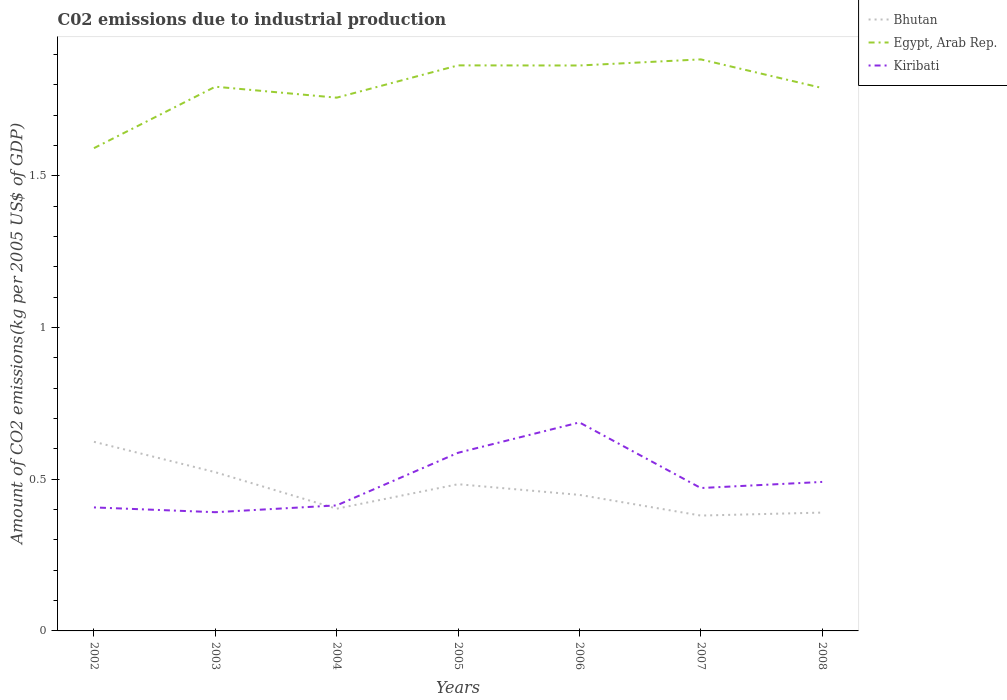How many different coloured lines are there?
Provide a succinct answer. 3. Does the line corresponding to Kiribati intersect with the line corresponding to Egypt, Arab Rep.?
Make the answer very short. No. Is the number of lines equal to the number of legend labels?
Your response must be concise. Yes. Across all years, what is the maximum amount of CO2 emitted due to industrial production in Kiribati?
Keep it short and to the point. 0.39. What is the total amount of CO2 emitted due to industrial production in Egypt, Arab Rep. in the graph?
Make the answer very short. -0.27. What is the difference between the highest and the second highest amount of CO2 emitted due to industrial production in Egypt, Arab Rep.?
Provide a succinct answer. 0.29. How many years are there in the graph?
Offer a very short reply. 7. Does the graph contain grids?
Your answer should be compact. No. How are the legend labels stacked?
Offer a very short reply. Vertical. What is the title of the graph?
Make the answer very short. C02 emissions due to industrial production. What is the label or title of the X-axis?
Make the answer very short. Years. What is the label or title of the Y-axis?
Your response must be concise. Amount of CO2 emissions(kg per 2005 US$ of GDP). What is the Amount of CO2 emissions(kg per 2005 US$ of GDP) in Bhutan in 2002?
Your answer should be very brief. 0.62. What is the Amount of CO2 emissions(kg per 2005 US$ of GDP) in Egypt, Arab Rep. in 2002?
Provide a short and direct response. 1.59. What is the Amount of CO2 emissions(kg per 2005 US$ of GDP) in Kiribati in 2002?
Ensure brevity in your answer.  0.41. What is the Amount of CO2 emissions(kg per 2005 US$ of GDP) in Bhutan in 2003?
Provide a short and direct response. 0.52. What is the Amount of CO2 emissions(kg per 2005 US$ of GDP) of Egypt, Arab Rep. in 2003?
Ensure brevity in your answer.  1.79. What is the Amount of CO2 emissions(kg per 2005 US$ of GDP) of Kiribati in 2003?
Your response must be concise. 0.39. What is the Amount of CO2 emissions(kg per 2005 US$ of GDP) in Bhutan in 2004?
Keep it short and to the point. 0.4. What is the Amount of CO2 emissions(kg per 2005 US$ of GDP) of Egypt, Arab Rep. in 2004?
Offer a very short reply. 1.76. What is the Amount of CO2 emissions(kg per 2005 US$ of GDP) in Kiribati in 2004?
Keep it short and to the point. 0.41. What is the Amount of CO2 emissions(kg per 2005 US$ of GDP) of Bhutan in 2005?
Offer a terse response. 0.48. What is the Amount of CO2 emissions(kg per 2005 US$ of GDP) of Egypt, Arab Rep. in 2005?
Give a very brief answer. 1.86. What is the Amount of CO2 emissions(kg per 2005 US$ of GDP) in Kiribati in 2005?
Provide a short and direct response. 0.59. What is the Amount of CO2 emissions(kg per 2005 US$ of GDP) of Bhutan in 2006?
Provide a succinct answer. 0.45. What is the Amount of CO2 emissions(kg per 2005 US$ of GDP) in Egypt, Arab Rep. in 2006?
Give a very brief answer. 1.86. What is the Amount of CO2 emissions(kg per 2005 US$ of GDP) in Kiribati in 2006?
Your response must be concise. 0.69. What is the Amount of CO2 emissions(kg per 2005 US$ of GDP) in Bhutan in 2007?
Your response must be concise. 0.38. What is the Amount of CO2 emissions(kg per 2005 US$ of GDP) in Egypt, Arab Rep. in 2007?
Give a very brief answer. 1.88. What is the Amount of CO2 emissions(kg per 2005 US$ of GDP) of Kiribati in 2007?
Provide a short and direct response. 0.47. What is the Amount of CO2 emissions(kg per 2005 US$ of GDP) in Bhutan in 2008?
Your answer should be compact. 0.39. What is the Amount of CO2 emissions(kg per 2005 US$ of GDP) in Egypt, Arab Rep. in 2008?
Your response must be concise. 1.79. What is the Amount of CO2 emissions(kg per 2005 US$ of GDP) of Kiribati in 2008?
Offer a terse response. 0.49. Across all years, what is the maximum Amount of CO2 emissions(kg per 2005 US$ of GDP) in Bhutan?
Offer a terse response. 0.62. Across all years, what is the maximum Amount of CO2 emissions(kg per 2005 US$ of GDP) in Egypt, Arab Rep.?
Give a very brief answer. 1.88. Across all years, what is the maximum Amount of CO2 emissions(kg per 2005 US$ of GDP) of Kiribati?
Your answer should be compact. 0.69. Across all years, what is the minimum Amount of CO2 emissions(kg per 2005 US$ of GDP) in Bhutan?
Provide a short and direct response. 0.38. Across all years, what is the minimum Amount of CO2 emissions(kg per 2005 US$ of GDP) in Egypt, Arab Rep.?
Keep it short and to the point. 1.59. Across all years, what is the minimum Amount of CO2 emissions(kg per 2005 US$ of GDP) in Kiribati?
Your answer should be compact. 0.39. What is the total Amount of CO2 emissions(kg per 2005 US$ of GDP) of Bhutan in the graph?
Make the answer very short. 3.25. What is the total Amount of CO2 emissions(kg per 2005 US$ of GDP) in Egypt, Arab Rep. in the graph?
Your answer should be compact. 12.55. What is the total Amount of CO2 emissions(kg per 2005 US$ of GDP) in Kiribati in the graph?
Your response must be concise. 3.45. What is the difference between the Amount of CO2 emissions(kg per 2005 US$ of GDP) in Bhutan in 2002 and that in 2003?
Your answer should be very brief. 0.1. What is the difference between the Amount of CO2 emissions(kg per 2005 US$ of GDP) in Egypt, Arab Rep. in 2002 and that in 2003?
Ensure brevity in your answer.  -0.2. What is the difference between the Amount of CO2 emissions(kg per 2005 US$ of GDP) in Kiribati in 2002 and that in 2003?
Provide a succinct answer. 0.02. What is the difference between the Amount of CO2 emissions(kg per 2005 US$ of GDP) of Bhutan in 2002 and that in 2004?
Offer a terse response. 0.22. What is the difference between the Amount of CO2 emissions(kg per 2005 US$ of GDP) of Egypt, Arab Rep. in 2002 and that in 2004?
Your answer should be very brief. -0.17. What is the difference between the Amount of CO2 emissions(kg per 2005 US$ of GDP) of Kiribati in 2002 and that in 2004?
Ensure brevity in your answer.  -0.01. What is the difference between the Amount of CO2 emissions(kg per 2005 US$ of GDP) in Bhutan in 2002 and that in 2005?
Ensure brevity in your answer.  0.14. What is the difference between the Amount of CO2 emissions(kg per 2005 US$ of GDP) of Egypt, Arab Rep. in 2002 and that in 2005?
Make the answer very short. -0.27. What is the difference between the Amount of CO2 emissions(kg per 2005 US$ of GDP) in Kiribati in 2002 and that in 2005?
Give a very brief answer. -0.18. What is the difference between the Amount of CO2 emissions(kg per 2005 US$ of GDP) in Bhutan in 2002 and that in 2006?
Your answer should be very brief. 0.18. What is the difference between the Amount of CO2 emissions(kg per 2005 US$ of GDP) of Egypt, Arab Rep. in 2002 and that in 2006?
Offer a terse response. -0.27. What is the difference between the Amount of CO2 emissions(kg per 2005 US$ of GDP) in Kiribati in 2002 and that in 2006?
Your answer should be very brief. -0.28. What is the difference between the Amount of CO2 emissions(kg per 2005 US$ of GDP) of Bhutan in 2002 and that in 2007?
Your response must be concise. 0.24. What is the difference between the Amount of CO2 emissions(kg per 2005 US$ of GDP) of Egypt, Arab Rep. in 2002 and that in 2007?
Keep it short and to the point. -0.29. What is the difference between the Amount of CO2 emissions(kg per 2005 US$ of GDP) in Kiribati in 2002 and that in 2007?
Provide a succinct answer. -0.06. What is the difference between the Amount of CO2 emissions(kg per 2005 US$ of GDP) in Bhutan in 2002 and that in 2008?
Make the answer very short. 0.23. What is the difference between the Amount of CO2 emissions(kg per 2005 US$ of GDP) of Egypt, Arab Rep. in 2002 and that in 2008?
Make the answer very short. -0.2. What is the difference between the Amount of CO2 emissions(kg per 2005 US$ of GDP) in Kiribati in 2002 and that in 2008?
Your answer should be compact. -0.08. What is the difference between the Amount of CO2 emissions(kg per 2005 US$ of GDP) of Bhutan in 2003 and that in 2004?
Keep it short and to the point. 0.12. What is the difference between the Amount of CO2 emissions(kg per 2005 US$ of GDP) of Egypt, Arab Rep. in 2003 and that in 2004?
Keep it short and to the point. 0.04. What is the difference between the Amount of CO2 emissions(kg per 2005 US$ of GDP) in Kiribati in 2003 and that in 2004?
Give a very brief answer. -0.02. What is the difference between the Amount of CO2 emissions(kg per 2005 US$ of GDP) of Bhutan in 2003 and that in 2005?
Offer a very short reply. 0.04. What is the difference between the Amount of CO2 emissions(kg per 2005 US$ of GDP) in Egypt, Arab Rep. in 2003 and that in 2005?
Provide a succinct answer. -0.07. What is the difference between the Amount of CO2 emissions(kg per 2005 US$ of GDP) of Kiribati in 2003 and that in 2005?
Provide a short and direct response. -0.2. What is the difference between the Amount of CO2 emissions(kg per 2005 US$ of GDP) of Bhutan in 2003 and that in 2006?
Provide a short and direct response. 0.07. What is the difference between the Amount of CO2 emissions(kg per 2005 US$ of GDP) of Egypt, Arab Rep. in 2003 and that in 2006?
Offer a terse response. -0.07. What is the difference between the Amount of CO2 emissions(kg per 2005 US$ of GDP) in Kiribati in 2003 and that in 2006?
Keep it short and to the point. -0.3. What is the difference between the Amount of CO2 emissions(kg per 2005 US$ of GDP) in Bhutan in 2003 and that in 2007?
Your response must be concise. 0.14. What is the difference between the Amount of CO2 emissions(kg per 2005 US$ of GDP) in Egypt, Arab Rep. in 2003 and that in 2007?
Your answer should be very brief. -0.09. What is the difference between the Amount of CO2 emissions(kg per 2005 US$ of GDP) in Kiribati in 2003 and that in 2007?
Provide a short and direct response. -0.08. What is the difference between the Amount of CO2 emissions(kg per 2005 US$ of GDP) of Bhutan in 2003 and that in 2008?
Offer a terse response. 0.13. What is the difference between the Amount of CO2 emissions(kg per 2005 US$ of GDP) of Egypt, Arab Rep. in 2003 and that in 2008?
Your answer should be compact. 0. What is the difference between the Amount of CO2 emissions(kg per 2005 US$ of GDP) in Kiribati in 2003 and that in 2008?
Provide a succinct answer. -0.1. What is the difference between the Amount of CO2 emissions(kg per 2005 US$ of GDP) of Bhutan in 2004 and that in 2005?
Your answer should be very brief. -0.08. What is the difference between the Amount of CO2 emissions(kg per 2005 US$ of GDP) in Egypt, Arab Rep. in 2004 and that in 2005?
Offer a very short reply. -0.11. What is the difference between the Amount of CO2 emissions(kg per 2005 US$ of GDP) of Kiribati in 2004 and that in 2005?
Your answer should be very brief. -0.17. What is the difference between the Amount of CO2 emissions(kg per 2005 US$ of GDP) in Bhutan in 2004 and that in 2006?
Your answer should be compact. -0.05. What is the difference between the Amount of CO2 emissions(kg per 2005 US$ of GDP) of Egypt, Arab Rep. in 2004 and that in 2006?
Your answer should be compact. -0.11. What is the difference between the Amount of CO2 emissions(kg per 2005 US$ of GDP) in Kiribati in 2004 and that in 2006?
Offer a terse response. -0.27. What is the difference between the Amount of CO2 emissions(kg per 2005 US$ of GDP) of Bhutan in 2004 and that in 2007?
Keep it short and to the point. 0.02. What is the difference between the Amount of CO2 emissions(kg per 2005 US$ of GDP) in Egypt, Arab Rep. in 2004 and that in 2007?
Offer a terse response. -0.13. What is the difference between the Amount of CO2 emissions(kg per 2005 US$ of GDP) of Kiribati in 2004 and that in 2007?
Ensure brevity in your answer.  -0.06. What is the difference between the Amount of CO2 emissions(kg per 2005 US$ of GDP) of Bhutan in 2004 and that in 2008?
Offer a terse response. 0.01. What is the difference between the Amount of CO2 emissions(kg per 2005 US$ of GDP) in Egypt, Arab Rep. in 2004 and that in 2008?
Ensure brevity in your answer.  -0.03. What is the difference between the Amount of CO2 emissions(kg per 2005 US$ of GDP) in Kiribati in 2004 and that in 2008?
Give a very brief answer. -0.08. What is the difference between the Amount of CO2 emissions(kg per 2005 US$ of GDP) in Bhutan in 2005 and that in 2006?
Ensure brevity in your answer.  0.04. What is the difference between the Amount of CO2 emissions(kg per 2005 US$ of GDP) in Egypt, Arab Rep. in 2005 and that in 2006?
Offer a very short reply. 0. What is the difference between the Amount of CO2 emissions(kg per 2005 US$ of GDP) of Kiribati in 2005 and that in 2006?
Ensure brevity in your answer.  -0.1. What is the difference between the Amount of CO2 emissions(kg per 2005 US$ of GDP) of Bhutan in 2005 and that in 2007?
Keep it short and to the point. 0.1. What is the difference between the Amount of CO2 emissions(kg per 2005 US$ of GDP) of Egypt, Arab Rep. in 2005 and that in 2007?
Make the answer very short. -0.02. What is the difference between the Amount of CO2 emissions(kg per 2005 US$ of GDP) in Kiribati in 2005 and that in 2007?
Your answer should be very brief. 0.12. What is the difference between the Amount of CO2 emissions(kg per 2005 US$ of GDP) in Bhutan in 2005 and that in 2008?
Your answer should be very brief. 0.09. What is the difference between the Amount of CO2 emissions(kg per 2005 US$ of GDP) in Egypt, Arab Rep. in 2005 and that in 2008?
Your answer should be very brief. 0.07. What is the difference between the Amount of CO2 emissions(kg per 2005 US$ of GDP) of Kiribati in 2005 and that in 2008?
Ensure brevity in your answer.  0.1. What is the difference between the Amount of CO2 emissions(kg per 2005 US$ of GDP) of Bhutan in 2006 and that in 2007?
Give a very brief answer. 0.07. What is the difference between the Amount of CO2 emissions(kg per 2005 US$ of GDP) of Egypt, Arab Rep. in 2006 and that in 2007?
Your answer should be very brief. -0.02. What is the difference between the Amount of CO2 emissions(kg per 2005 US$ of GDP) in Kiribati in 2006 and that in 2007?
Give a very brief answer. 0.22. What is the difference between the Amount of CO2 emissions(kg per 2005 US$ of GDP) of Bhutan in 2006 and that in 2008?
Keep it short and to the point. 0.06. What is the difference between the Amount of CO2 emissions(kg per 2005 US$ of GDP) in Egypt, Arab Rep. in 2006 and that in 2008?
Your response must be concise. 0.07. What is the difference between the Amount of CO2 emissions(kg per 2005 US$ of GDP) in Kiribati in 2006 and that in 2008?
Keep it short and to the point. 0.2. What is the difference between the Amount of CO2 emissions(kg per 2005 US$ of GDP) in Bhutan in 2007 and that in 2008?
Your answer should be compact. -0.01. What is the difference between the Amount of CO2 emissions(kg per 2005 US$ of GDP) of Egypt, Arab Rep. in 2007 and that in 2008?
Give a very brief answer. 0.09. What is the difference between the Amount of CO2 emissions(kg per 2005 US$ of GDP) in Kiribati in 2007 and that in 2008?
Provide a succinct answer. -0.02. What is the difference between the Amount of CO2 emissions(kg per 2005 US$ of GDP) in Bhutan in 2002 and the Amount of CO2 emissions(kg per 2005 US$ of GDP) in Egypt, Arab Rep. in 2003?
Offer a very short reply. -1.17. What is the difference between the Amount of CO2 emissions(kg per 2005 US$ of GDP) of Bhutan in 2002 and the Amount of CO2 emissions(kg per 2005 US$ of GDP) of Kiribati in 2003?
Provide a succinct answer. 0.23. What is the difference between the Amount of CO2 emissions(kg per 2005 US$ of GDP) in Egypt, Arab Rep. in 2002 and the Amount of CO2 emissions(kg per 2005 US$ of GDP) in Kiribati in 2003?
Offer a terse response. 1.2. What is the difference between the Amount of CO2 emissions(kg per 2005 US$ of GDP) in Bhutan in 2002 and the Amount of CO2 emissions(kg per 2005 US$ of GDP) in Egypt, Arab Rep. in 2004?
Ensure brevity in your answer.  -1.13. What is the difference between the Amount of CO2 emissions(kg per 2005 US$ of GDP) of Bhutan in 2002 and the Amount of CO2 emissions(kg per 2005 US$ of GDP) of Kiribati in 2004?
Make the answer very short. 0.21. What is the difference between the Amount of CO2 emissions(kg per 2005 US$ of GDP) in Egypt, Arab Rep. in 2002 and the Amount of CO2 emissions(kg per 2005 US$ of GDP) in Kiribati in 2004?
Provide a short and direct response. 1.18. What is the difference between the Amount of CO2 emissions(kg per 2005 US$ of GDP) of Bhutan in 2002 and the Amount of CO2 emissions(kg per 2005 US$ of GDP) of Egypt, Arab Rep. in 2005?
Give a very brief answer. -1.24. What is the difference between the Amount of CO2 emissions(kg per 2005 US$ of GDP) in Bhutan in 2002 and the Amount of CO2 emissions(kg per 2005 US$ of GDP) in Kiribati in 2005?
Your answer should be compact. 0.04. What is the difference between the Amount of CO2 emissions(kg per 2005 US$ of GDP) in Egypt, Arab Rep. in 2002 and the Amount of CO2 emissions(kg per 2005 US$ of GDP) in Kiribati in 2005?
Provide a short and direct response. 1. What is the difference between the Amount of CO2 emissions(kg per 2005 US$ of GDP) in Bhutan in 2002 and the Amount of CO2 emissions(kg per 2005 US$ of GDP) in Egypt, Arab Rep. in 2006?
Give a very brief answer. -1.24. What is the difference between the Amount of CO2 emissions(kg per 2005 US$ of GDP) of Bhutan in 2002 and the Amount of CO2 emissions(kg per 2005 US$ of GDP) of Kiribati in 2006?
Keep it short and to the point. -0.06. What is the difference between the Amount of CO2 emissions(kg per 2005 US$ of GDP) in Egypt, Arab Rep. in 2002 and the Amount of CO2 emissions(kg per 2005 US$ of GDP) in Kiribati in 2006?
Your answer should be very brief. 0.9. What is the difference between the Amount of CO2 emissions(kg per 2005 US$ of GDP) in Bhutan in 2002 and the Amount of CO2 emissions(kg per 2005 US$ of GDP) in Egypt, Arab Rep. in 2007?
Ensure brevity in your answer.  -1.26. What is the difference between the Amount of CO2 emissions(kg per 2005 US$ of GDP) in Bhutan in 2002 and the Amount of CO2 emissions(kg per 2005 US$ of GDP) in Kiribati in 2007?
Give a very brief answer. 0.15. What is the difference between the Amount of CO2 emissions(kg per 2005 US$ of GDP) in Egypt, Arab Rep. in 2002 and the Amount of CO2 emissions(kg per 2005 US$ of GDP) in Kiribati in 2007?
Provide a short and direct response. 1.12. What is the difference between the Amount of CO2 emissions(kg per 2005 US$ of GDP) of Bhutan in 2002 and the Amount of CO2 emissions(kg per 2005 US$ of GDP) of Egypt, Arab Rep. in 2008?
Your response must be concise. -1.17. What is the difference between the Amount of CO2 emissions(kg per 2005 US$ of GDP) in Bhutan in 2002 and the Amount of CO2 emissions(kg per 2005 US$ of GDP) in Kiribati in 2008?
Your response must be concise. 0.13. What is the difference between the Amount of CO2 emissions(kg per 2005 US$ of GDP) of Egypt, Arab Rep. in 2002 and the Amount of CO2 emissions(kg per 2005 US$ of GDP) of Kiribati in 2008?
Your answer should be compact. 1.1. What is the difference between the Amount of CO2 emissions(kg per 2005 US$ of GDP) of Bhutan in 2003 and the Amount of CO2 emissions(kg per 2005 US$ of GDP) of Egypt, Arab Rep. in 2004?
Ensure brevity in your answer.  -1.23. What is the difference between the Amount of CO2 emissions(kg per 2005 US$ of GDP) of Bhutan in 2003 and the Amount of CO2 emissions(kg per 2005 US$ of GDP) of Kiribati in 2004?
Your response must be concise. 0.11. What is the difference between the Amount of CO2 emissions(kg per 2005 US$ of GDP) of Egypt, Arab Rep. in 2003 and the Amount of CO2 emissions(kg per 2005 US$ of GDP) of Kiribati in 2004?
Give a very brief answer. 1.38. What is the difference between the Amount of CO2 emissions(kg per 2005 US$ of GDP) in Bhutan in 2003 and the Amount of CO2 emissions(kg per 2005 US$ of GDP) in Egypt, Arab Rep. in 2005?
Offer a very short reply. -1.34. What is the difference between the Amount of CO2 emissions(kg per 2005 US$ of GDP) of Bhutan in 2003 and the Amount of CO2 emissions(kg per 2005 US$ of GDP) of Kiribati in 2005?
Provide a short and direct response. -0.06. What is the difference between the Amount of CO2 emissions(kg per 2005 US$ of GDP) in Egypt, Arab Rep. in 2003 and the Amount of CO2 emissions(kg per 2005 US$ of GDP) in Kiribati in 2005?
Provide a short and direct response. 1.21. What is the difference between the Amount of CO2 emissions(kg per 2005 US$ of GDP) in Bhutan in 2003 and the Amount of CO2 emissions(kg per 2005 US$ of GDP) in Egypt, Arab Rep. in 2006?
Give a very brief answer. -1.34. What is the difference between the Amount of CO2 emissions(kg per 2005 US$ of GDP) of Bhutan in 2003 and the Amount of CO2 emissions(kg per 2005 US$ of GDP) of Kiribati in 2006?
Make the answer very short. -0.16. What is the difference between the Amount of CO2 emissions(kg per 2005 US$ of GDP) of Egypt, Arab Rep. in 2003 and the Amount of CO2 emissions(kg per 2005 US$ of GDP) of Kiribati in 2006?
Offer a terse response. 1.11. What is the difference between the Amount of CO2 emissions(kg per 2005 US$ of GDP) in Bhutan in 2003 and the Amount of CO2 emissions(kg per 2005 US$ of GDP) in Egypt, Arab Rep. in 2007?
Offer a terse response. -1.36. What is the difference between the Amount of CO2 emissions(kg per 2005 US$ of GDP) of Bhutan in 2003 and the Amount of CO2 emissions(kg per 2005 US$ of GDP) of Kiribati in 2007?
Offer a terse response. 0.05. What is the difference between the Amount of CO2 emissions(kg per 2005 US$ of GDP) in Egypt, Arab Rep. in 2003 and the Amount of CO2 emissions(kg per 2005 US$ of GDP) in Kiribati in 2007?
Make the answer very short. 1.32. What is the difference between the Amount of CO2 emissions(kg per 2005 US$ of GDP) of Bhutan in 2003 and the Amount of CO2 emissions(kg per 2005 US$ of GDP) of Egypt, Arab Rep. in 2008?
Make the answer very short. -1.27. What is the difference between the Amount of CO2 emissions(kg per 2005 US$ of GDP) of Bhutan in 2003 and the Amount of CO2 emissions(kg per 2005 US$ of GDP) of Kiribati in 2008?
Your answer should be compact. 0.03. What is the difference between the Amount of CO2 emissions(kg per 2005 US$ of GDP) of Egypt, Arab Rep. in 2003 and the Amount of CO2 emissions(kg per 2005 US$ of GDP) of Kiribati in 2008?
Provide a succinct answer. 1.3. What is the difference between the Amount of CO2 emissions(kg per 2005 US$ of GDP) in Bhutan in 2004 and the Amount of CO2 emissions(kg per 2005 US$ of GDP) in Egypt, Arab Rep. in 2005?
Your response must be concise. -1.46. What is the difference between the Amount of CO2 emissions(kg per 2005 US$ of GDP) in Bhutan in 2004 and the Amount of CO2 emissions(kg per 2005 US$ of GDP) in Kiribati in 2005?
Offer a very short reply. -0.18. What is the difference between the Amount of CO2 emissions(kg per 2005 US$ of GDP) of Egypt, Arab Rep. in 2004 and the Amount of CO2 emissions(kg per 2005 US$ of GDP) of Kiribati in 2005?
Give a very brief answer. 1.17. What is the difference between the Amount of CO2 emissions(kg per 2005 US$ of GDP) in Bhutan in 2004 and the Amount of CO2 emissions(kg per 2005 US$ of GDP) in Egypt, Arab Rep. in 2006?
Offer a terse response. -1.46. What is the difference between the Amount of CO2 emissions(kg per 2005 US$ of GDP) of Bhutan in 2004 and the Amount of CO2 emissions(kg per 2005 US$ of GDP) of Kiribati in 2006?
Your response must be concise. -0.28. What is the difference between the Amount of CO2 emissions(kg per 2005 US$ of GDP) in Egypt, Arab Rep. in 2004 and the Amount of CO2 emissions(kg per 2005 US$ of GDP) in Kiribati in 2006?
Your answer should be very brief. 1.07. What is the difference between the Amount of CO2 emissions(kg per 2005 US$ of GDP) of Bhutan in 2004 and the Amount of CO2 emissions(kg per 2005 US$ of GDP) of Egypt, Arab Rep. in 2007?
Keep it short and to the point. -1.48. What is the difference between the Amount of CO2 emissions(kg per 2005 US$ of GDP) in Bhutan in 2004 and the Amount of CO2 emissions(kg per 2005 US$ of GDP) in Kiribati in 2007?
Your response must be concise. -0.07. What is the difference between the Amount of CO2 emissions(kg per 2005 US$ of GDP) of Egypt, Arab Rep. in 2004 and the Amount of CO2 emissions(kg per 2005 US$ of GDP) of Kiribati in 2007?
Ensure brevity in your answer.  1.29. What is the difference between the Amount of CO2 emissions(kg per 2005 US$ of GDP) of Bhutan in 2004 and the Amount of CO2 emissions(kg per 2005 US$ of GDP) of Egypt, Arab Rep. in 2008?
Your answer should be compact. -1.39. What is the difference between the Amount of CO2 emissions(kg per 2005 US$ of GDP) in Bhutan in 2004 and the Amount of CO2 emissions(kg per 2005 US$ of GDP) in Kiribati in 2008?
Your response must be concise. -0.09. What is the difference between the Amount of CO2 emissions(kg per 2005 US$ of GDP) of Egypt, Arab Rep. in 2004 and the Amount of CO2 emissions(kg per 2005 US$ of GDP) of Kiribati in 2008?
Provide a succinct answer. 1.27. What is the difference between the Amount of CO2 emissions(kg per 2005 US$ of GDP) of Bhutan in 2005 and the Amount of CO2 emissions(kg per 2005 US$ of GDP) of Egypt, Arab Rep. in 2006?
Keep it short and to the point. -1.38. What is the difference between the Amount of CO2 emissions(kg per 2005 US$ of GDP) in Bhutan in 2005 and the Amount of CO2 emissions(kg per 2005 US$ of GDP) in Kiribati in 2006?
Offer a very short reply. -0.2. What is the difference between the Amount of CO2 emissions(kg per 2005 US$ of GDP) of Egypt, Arab Rep. in 2005 and the Amount of CO2 emissions(kg per 2005 US$ of GDP) of Kiribati in 2006?
Give a very brief answer. 1.18. What is the difference between the Amount of CO2 emissions(kg per 2005 US$ of GDP) in Bhutan in 2005 and the Amount of CO2 emissions(kg per 2005 US$ of GDP) in Egypt, Arab Rep. in 2007?
Your answer should be compact. -1.4. What is the difference between the Amount of CO2 emissions(kg per 2005 US$ of GDP) in Bhutan in 2005 and the Amount of CO2 emissions(kg per 2005 US$ of GDP) in Kiribati in 2007?
Provide a short and direct response. 0.01. What is the difference between the Amount of CO2 emissions(kg per 2005 US$ of GDP) in Egypt, Arab Rep. in 2005 and the Amount of CO2 emissions(kg per 2005 US$ of GDP) in Kiribati in 2007?
Offer a very short reply. 1.39. What is the difference between the Amount of CO2 emissions(kg per 2005 US$ of GDP) in Bhutan in 2005 and the Amount of CO2 emissions(kg per 2005 US$ of GDP) in Egypt, Arab Rep. in 2008?
Your answer should be very brief. -1.31. What is the difference between the Amount of CO2 emissions(kg per 2005 US$ of GDP) of Bhutan in 2005 and the Amount of CO2 emissions(kg per 2005 US$ of GDP) of Kiribati in 2008?
Make the answer very short. -0.01. What is the difference between the Amount of CO2 emissions(kg per 2005 US$ of GDP) of Egypt, Arab Rep. in 2005 and the Amount of CO2 emissions(kg per 2005 US$ of GDP) of Kiribati in 2008?
Provide a succinct answer. 1.37. What is the difference between the Amount of CO2 emissions(kg per 2005 US$ of GDP) in Bhutan in 2006 and the Amount of CO2 emissions(kg per 2005 US$ of GDP) in Egypt, Arab Rep. in 2007?
Provide a succinct answer. -1.44. What is the difference between the Amount of CO2 emissions(kg per 2005 US$ of GDP) in Bhutan in 2006 and the Amount of CO2 emissions(kg per 2005 US$ of GDP) in Kiribati in 2007?
Provide a short and direct response. -0.02. What is the difference between the Amount of CO2 emissions(kg per 2005 US$ of GDP) of Egypt, Arab Rep. in 2006 and the Amount of CO2 emissions(kg per 2005 US$ of GDP) of Kiribati in 2007?
Provide a short and direct response. 1.39. What is the difference between the Amount of CO2 emissions(kg per 2005 US$ of GDP) of Bhutan in 2006 and the Amount of CO2 emissions(kg per 2005 US$ of GDP) of Egypt, Arab Rep. in 2008?
Make the answer very short. -1.34. What is the difference between the Amount of CO2 emissions(kg per 2005 US$ of GDP) of Bhutan in 2006 and the Amount of CO2 emissions(kg per 2005 US$ of GDP) of Kiribati in 2008?
Your response must be concise. -0.04. What is the difference between the Amount of CO2 emissions(kg per 2005 US$ of GDP) of Egypt, Arab Rep. in 2006 and the Amount of CO2 emissions(kg per 2005 US$ of GDP) of Kiribati in 2008?
Ensure brevity in your answer.  1.37. What is the difference between the Amount of CO2 emissions(kg per 2005 US$ of GDP) of Bhutan in 2007 and the Amount of CO2 emissions(kg per 2005 US$ of GDP) of Egypt, Arab Rep. in 2008?
Make the answer very short. -1.41. What is the difference between the Amount of CO2 emissions(kg per 2005 US$ of GDP) of Bhutan in 2007 and the Amount of CO2 emissions(kg per 2005 US$ of GDP) of Kiribati in 2008?
Provide a short and direct response. -0.11. What is the difference between the Amount of CO2 emissions(kg per 2005 US$ of GDP) of Egypt, Arab Rep. in 2007 and the Amount of CO2 emissions(kg per 2005 US$ of GDP) of Kiribati in 2008?
Make the answer very short. 1.39. What is the average Amount of CO2 emissions(kg per 2005 US$ of GDP) of Bhutan per year?
Offer a terse response. 0.46. What is the average Amount of CO2 emissions(kg per 2005 US$ of GDP) of Egypt, Arab Rep. per year?
Offer a very short reply. 1.79. What is the average Amount of CO2 emissions(kg per 2005 US$ of GDP) in Kiribati per year?
Your response must be concise. 0.49. In the year 2002, what is the difference between the Amount of CO2 emissions(kg per 2005 US$ of GDP) of Bhutan and Amount of CO2 emissions(kg per 2005 US$ of GDP) of Egypt, Arab Rep.?
Offer a terse response. -0.97. In the year 2002, what is the difference between the Amount of CO2 emissions(kg per 2005 US$ of GDP) of Bhutan and Amount of CO2 emissions(kg per 2005 US$ of GDP) of Kiribati?
Ensure brevity in your answer.  0.22. In the year 2002, what is the difference between the Amount of CO2 emissions(kg per 2005 US$ of GDP) in Egypt, Arab Rep. and Amount of CO2 emissions(kg per 2005 US$ of GDP) in Kiribati?
Offer a terse response. 1.18. In the year 2003, what is the difference between the Amount of CO2 emissions(kg per 2005 US$ of GDP) of Bhutan and Amount of CO2 emissions(kg per 2005 US$ of GDP) of Egypt, Arab Rep.?
Give a very brief answer. -1.27. In the year 2003, what is the difference between the Amount of CO2 emissions(kg per 2005 US$ of GDP) in Bhutan and Amount of CO2 emissions(kg per 2005 US$ of GDP) in Kiribati?
Offer a terse response. 0.13. In the year 2003, what is the difference between the Amount of CO2 emissions(kg per 2005 US$ of GDP) of Egypt, Arab Rep. and Amount of CO2 emissions(kg per 2005 US$ of GDP) of Kiribati?
Give a very brief answer. 1.4. In the year 2004, what is the difference between the Amount of CO2 emissions(kg per 2005 US$ of GDP) in Bhutan and Amount of CO2 emissions(kg per 2005 US$ of GDP) in Egypt, Arab Rep.?
Make the answer very short. -1.35. In the year 2004, what is the difference between the Amount of CO2 emissions(kg per 2005 US$ of GDP) of Bhutan and Amount of CO2 emissions(kg per 2005 US$ of GDP) of Kiribati?
Provide a short and direct response. -0.01. In the year 2004, what is the difference between the Amount of CO2 emissions(kg per 2005 US$ of GDP) of Egypt, Arab Rep. and Amount of CO2 emissions(kg per 2005 US$ of GDP) of Kiribati?
Give a very brief answer. 1.34. In the year 2005, what is the difference between the Amount of CO2 emissions(kg per 2005 US$ of GDP) of Bhutan and Amount of CO2 emissions(kg per 2005 US$ of GDP) of Egypt, Arab Rep.?
Your answer should be very brief. -1.38. In the year 2005, what is the difference between the Amount of CO2 emissions(kg per 2005 US$ of GDP) of Bhutan and Amount of CO2 emissions(kg per 2005 US$ of GDP) of Kiribati?
Provide a succinct answer. -0.1. In the year 2005, what is the difference between the Amount of CO2 emissions(kg per 2005 US$ of GDP) of Egypt, Arab Rep. and Amount of CO2 emissions(kg per 2005 US$ of GDP) of Kiribati?
Your response must be concise. 1.28. In the year 2006, what is the difference between the Amount of CO2 emissions(kg per 2005 US$ of GDP) of Bhutan and Amount of CO2 emissions(kg per 2005 US$ of GDP) of Egypt, Arab Rep.?
Provide a succinct answer. -1.42. In the year 2006, what is the difference between the Amount of CO2 emissions(kg per 2005 US$ of GDP) of Bhutan and Amount of CO2 emissions(kg per 2005 US$ of GDP) of Kiribati?
Your response must be concise. -0.24. In the year 2006, what is the difference between the Amount of CO2 emissions(kg per 2005 US$ of GDP) in Egypt, Arab Rep. and Amount of CO2 emissions(kg per 2005 US$ of GDP) in Kiribati?
Your answer should be compact. 1.18. In the year 2007, what is the difference between the Amount of CO2 emissions(kg per 2005 US$ of GDP) of Bhutan and Amount of CO2 emissions(kg per 2005 US$ of GDP) of Egypt, Arab Rep.?
Your answer should be very brief. -1.5. In the year 2007, what is the difference between the Amount of CO2 emissions(kg per 2005 US$ of GDP) in Bhutan and Amount of CO2 emissions(kg per 2005 US$ of GDP) in Kiribati?
Your answer should be very brief. -0.09. In the year 2007, what is the difference between the Amount of CO2 emissions(kg per 2005 US$ of GDP) in Egypt, Arab Rep. and Amount of CO2 emissions(kg per 2005 US$ of GDP) in Kiribati?
Give a very brief answer. 1.41. In the year 2008, what is the difference between the Amount of CO2 emissions(kg per 2005 US$ of GDP) of Bhutan and Amount of CO2 emissions(kg per 2005 US$ of GDP) of Egypt, Arab Rep.?
Keep it short and to the point. -1.4. In the year 2008, what is the difference between the Amount of CO2 emissions(kg per 2005 US$ of GDP) of Bhutan and Amount of CO2 emissions(kg per 2005 US$ of GDP) of Kiribati?
Give a very brief answer. -0.1. In the year 2008, what is the difference between the Amount of CO2 emissions(kg per 2005 US$ of GDP) in Egypt, Arab Rep. and Amount of CO2 emissions(kg per 2005 US$ of GDP) in Kiribati?
Your answer should be very brief. 1.3. What is the ratio of the Amount of CO2 emissions(kg per 2005 US$ of GDP) of Bhutan in 2002 to that in 2003?
Offer a terse response. 1.19. What is the ratio of the Amount of CO2 emissions(kg per 2005 US$ of GDP) in Egypt, Arab Rep. in 2002 to that in 2003?
Ensure brevity in your answer.  0.89. What is the ratio of the Amount of CO2 emissions(kg per 2005 US$ of GDP) in Kiribati in 2002 to that in 2003?
Your answer should be compact. 1.04. What is the ratio of the Amount of CO2 emissions(kg per 2005 US$ of GDP) in Bhutan in 2002 to that in 2004?
Provide a succinct answer. 1.55. What is the ratio of the Amount of CO2 emissions(kg per 2005 US$ of GDP) in Egypt, Arab Rep. in 2002 to that in 2004?
Provide a short and direct response. 0.91. What is the ratio of the Amount of CO2 emissions(kg per 2005 US$ of GDP) of Kiribati in 2002 to that in 2004?
Give a very brief answer. 0.98. What is the ratio of the Amount of CO2 emissions(kg per 2005 US$ of GDP) of Bhutan in 2002 to that in 2005?
Ensure brevity in your answer.  1.29. What is the ratio of the Amount of CO2 emissions(kg per 2005 US$ of GDP) of Egypt, Arab Rep. in 2002 to that in 2005?
Give a very brief answer. 0.85. What is the ratio of the Amount of CO2 emissions(kg per 2005 US$ of GDP) in Kiribati in 2002 to that in 2005?
Keep it short and to the point. 0.69. What is the ratio of the Amount of CO2 emissions(kg per 2005 US$ of GDP) of Bhutan in 2002 to that in 2006?
Provide a short and direct response. 1.39. What is the ratio of the Amount of CO2 emissions(kg per 2005 US$ of GDP) of Egypt, Arab Rep. in 2002 to that in 2006?
Offer a terse response. 0.85. What is the ratio of the Amount of CO2 emissions(kg per 2005 US$ of GDP) of Kiribati in 2002 to that in 2006?
Provide a short and direct response. 0.59. What is the ratio of the Amount of CO2 emissions(kg per 2005 US$ of GDP) of Bhutan in 2002 to that in 2007?
Ensure brevity in your answer.  1.64. What is the ratio of the Amount of CO2 emissions(kg per 2005 US$ of GDP) in Egypt, Arab Rep. in 2002 to that in 2007?
Your response must be concise. 0.84. What is the ratio of the Amount of CO2 emissions(kg per 2005 US$ of GDP) in Kiribati in 2002 to that in 2007?
Give a very brief answer. 0.86. What is the ratio of the Amount of CO2 emissions(kg per 2005 US$ of GDP) of Bhutan in 2002 to that in 2008?
Make the answer very short. 1.6. What is the ratio of the Amount of CO2 emissions(kg per 2005 US$ of GDP) in Egypt, Arab Rep. in 2002 to that in 2008?
Your answer should be compact. 0.89. What is the ratio of the Amount of CO2 emissions(kg per 2005 US$ of GDP) in Kiribati in 2002 to that in 2008?
Give a very brief answer. 0.83. What is the ratio of the Amount of CO2 emissions(kg per 2005 US$ of GDP) in Bhutan in 2003 to that in 2004?
Your answer should be very brief. 1.3. What is the ratio of the Amount of CO2 emissions(kg per 2005 US$ of GDP) in Egypt, Arab Rep. in 2003 to that in 2004?
Provide a short and direct response. 1.02. What is the ratio of the Amount of CO2 emissions(kg per 2005 US$ of GDP) of Kiribati in 2003 to that in 2004?
Provide a succinct answer. 0.95. What is the ratio of the Amount of CO2 emissions(kg per 2005 US$ of GDP) of Bhutan in 2003 to that in 2005?
Your response must be concise. 1.08. What is the ratio of the Amount of CO2 emissions(kg per 2005 US$ of GDP) in Egypt, Arab Rep. in 2003 to that in 2005?
Your answer should be very brief. 0.96. What is the ratio of the Amount of CO2 emissions(kg per 2005 US$ of GDP) in Kiribati in 2003 to that in 2005?
Your response must be concise. 0.67. What is the ratio of the Amount of CO2 emissions(kg per 2005 US$ of GDP) of Bhutan in 2003 to that in 2006?
Keep it short and to the point. 1.17. What is the ratio of the Amount of CO2 emissions(kg per 2005 US$ of GDP) in Egypt, Arab Rep. in 2003 to that in 2006?
Ensure brevity in your answer.  0.96. What is the ratio of the Amount of CO2 emissions(kg per 2005 US$ of GDP) of Kiribati in 2003 to that in 2006?
Your answer should be very brief. 0.57. What is the ratio of the Amount of CO2 emissions(kg per 2005 US$ of GDP) in Bhutan in 2003 to that in 2007?
Keep it short and to the point. 1.38. What is the ratio of the Amount of CO2 emissions(kg per 2005 US$ of GDP) in Egypt, Arab Rep. in 2003 to that in 2007?
Provide a succinct answer. 0.95. What is the ratio of the Amount of CO2 emissions(kg per 2005 US$ of GDP) in Kiribati in 2003 to that in 2007?
Make the answer very short. 0.83. What is the ratio of the Amount of CO2 emissions(kg per 2005 US$ of GDP) in Bhutan in 2003 to that in 2008?
Your response must be concise. 1.34. What is the ratio of the Amount of CO2 emissions(kg per 2005 US$ of GDP) in Egypt, Arab Rep. in 2003 to that in 2008?
Offer a very short reply. 1. What is the ratio of the Amount of CO2 emissions(kg per 2005 US$ of GDP) in Kiribati in 2003 to that in 2008?
Keep it short and to the point. 0.8. What is the ratio of the Amount of CO2 emissions(kg per 2005 US$ of GDP) in Bhutan in 2004 to that in 2005?
Keep it short and to the point. 0.83. What is the ratio of the Amount of CO2 emissions(kg per 2005 US$ of GDP) in Egypt, Arab Rep. in 2004 to that in 2005?
Provide a short and direct response. 0.94. What is the ratio of the Amount of CO2 emissions(kg per 2005 US$ of GDP) of Kiribati in 2004 to that in 2005?
Give a very brief answer. 0.7. What is the ratio of the Amount of CO2 emissions(kg per 2005 US$ of GDP) of Bhutan in 2004 to that in 2006?
Your answer should be very brief. 0.9. What is the ratio of the Amount of CO2 emissions(kg per 2005 US$ of GDP) of Egypt, Arab Rep. in 2004 to that in 2006?
Your answer should be very brief. 0.94. What is the ratio of the Amount of CO2 emissions(kg per 2005 US$ of GDP) of Kiribati in 2004 to that in 2006?
Keep it short and to the point. 0.6. What is the ratio of the Amount of CO2 emissions(kg per 2005 US$ of GDP) of Bhutan in 2004 to that in 2007?
Offer a very short reply. 1.06. What is the ratio of the Amount of CO2 emissions(kg per 2005 US$ of GDP) in Egypt, Arab Rep. in 2004 to that in 2007?
Your answer should be compact. 0.93. What is the ratio of the Amount of CO2 emissions(kg per 2005 US$ of GDP) of Kiribati in 2004 to that in 2007?
Offer a terse response. 0.88. What is the ratio of the Amount of CO2 emissions(kg per 2005 US$ of GDP) in Bhutan in 2004 to that in 2008?
Ensure brevity in your answer.  1.03. What is the ratio of the Amount of CO2 emissions(kg per 2005 US$ of GDP) in Egypt, Arab Rep. in 2004 to that in 2008?
Keep it short and to the point. 0.98. What is the ratio of the Amount of CO2 emissions(kg per 2005 US$ of GDP) in Kiribati in 2004 to that in 2008?
Ensure brevity in your answer.  0.84. What is the ratio of the Amount of CO2 emissions(kg per 2005 US$ of GDP) in Bhutan in 2005 to that in 2006?
Give a very brief answer. 1.08. What is the ratio of the Amount of CO2 emissions(kg per 2005 US$ of GDP) of Egypt, Arab Rep. in 2005 to that in 2006?
Your answer should be very brief. 1. What is the ratio of the Amount of CO2 emissions(kg per 2005 US$ of GDP) in Kiribati in 2005 to that in 2006?
Make the answer very short. 0.85. What is the ratio of the Amount of CO2 emissions(kg per 2005 US$ of GDP) in Bhutan in 2005 to that in 2007?
Keep it short and to the point. 1.27. What is the ratio of the Amount of CO2 emissions(kg per 2005 US$ of GDP) in Egypt, Arab Rep. in 2005 to that in 2007?
Your response must be concise. 0.99. What is the ratio of the Amount of CO2 emissions(kg per 2005 US$ of GDP) in Kiribati in 2005 to that in 2007?
Provide a succinct answer. 1.25. What is the ratio of the Amount of CO2 emissions(kg per 2005 US$ of GDP) of Bhutan in 2005 to that in 2008?
Offer a terse response. 1.24. What is the ratio of the Amount of CO2 emissions(kg per 2005 US$ of GDP) of Egypt, Arab Rep. in 2005 to that in 2008?
Offer a very short reply. 1.04. What is the ratio of the Amount of CO2 emissions(kg per 2005 US$ of GDP) in Kiribati in 2005 to that in 2008?
Ensure brevity in your answer.  1.2. What is the ratio of the Amount of CO2 emissions(kg per 2005 US$ of GDP) in Bhutan in 2006 to that in 2007?
Ensure brevity in your answer.  1.18. What is the ratio of the Amount of CO2 emissions(kg per 2005 US$ of GDP) of Egypt, Arab Rep. in 2006 to that in 2007?
Your answer should be very brief. 0.99. What is the ratio of the Amount of CO2 emissions(kg per 2005 US$ of GDP) in Kiribati in 2006 to that in 2007?
Your answer should be compact. 1.46. What is the ratio of the Amount of CO2 emissions(kg per 2005 US$ of GDP) of Bhutan in 2006 to that in 2008?
Ensure brevity in your answer.  1.15. What is the ratio of the Amount of CO2 emissions(kg per 2005 US$ of GDP) in Egypt, Arab Rep. in 2006 to that in 2008?
Offer a very short reply. 1.04. What is the ratio of the Amount of CO2 emissions(kg per 2005 US$ of GDP) of Kiribati in 2006 to that in 2008?
Provide a short and direct response. 1.4. What is the ratio of the Amount of CO2 emissions(kg per 2005 US$ of GDP) of Bhutan in 2007 to that in 2008?
Provide a short and direct response. 0.97. What is the ratio of the Amount of CO2 emissions(kg per 2005 US$ of GDP) of Egypt, Arab Rep. in 2007 to that in 2008?
Provide a succinct answer. 1.05. What is the difference between the highest and the second highest Amount of CO2 emissions(kg per 2005 US$ of GDP) of Bhutan?
Provide a short and direct response. 0.1. What is the difference between the highest and the second highest Amount of CO2 emissions(kg per 2005 US$ of GDP) in Egypt, Arab Rep.?
Ensure brevity in your answer.  0.02. What is the difference between the highest and the second highest Amount of CO2 emissions(kg per 2005 US$ of GDP) in Kiribati?
Your answer should be compact. 0.1. What is the difference between the highest and the lowest Amount of CO2 emissions(kg per 2005 US$ of GDP) in Bhutan?
Offer a very short reply. 0.24. What is the difference between the highest and the lowest Amount of CO2 emissions(kg per 2005 US$ of GDP) in Egypt, Arab Rep.?
Keep it short and to the point. 0.29. What is the difference between the highest and the lowest Amount of CO2 emissions(kg per 2005 US$ of GDP) of Kiribati?
Provide a short and direct response. 0.3. 